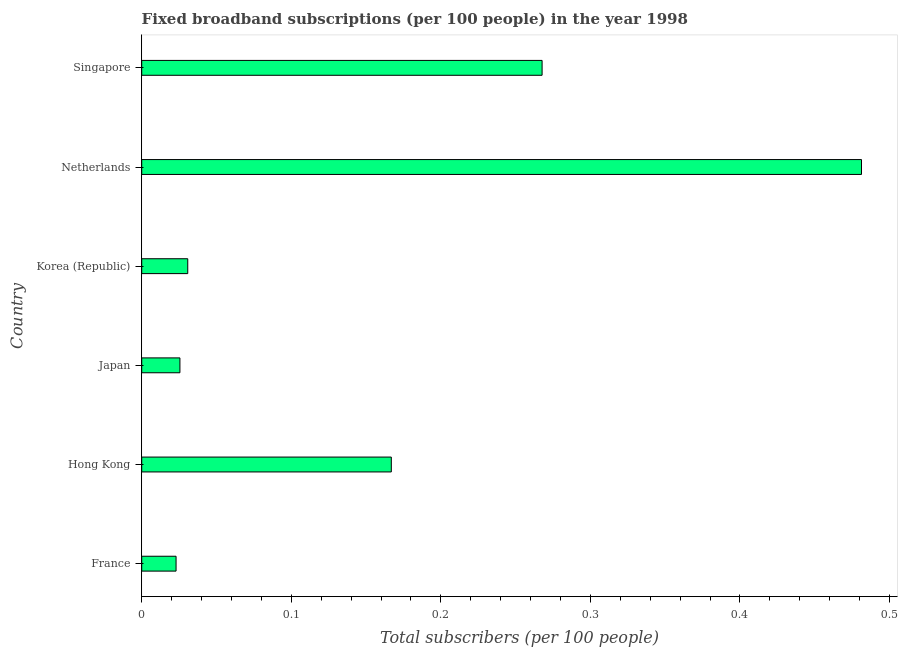What is the title of the graph?
Your response must be concise. Fixed broadband subscriptions (per 100 people) in the year 1998. What is the label or title of the X-axis?
Provide a succinct answer. Total subscribers (per 100 people). What is the label or title of the Y-axis?
Give a very brief answer. Country. What is the total number of fixed broadband subscriptions in Netherlands?
Provide a succinct answer. 0.48. Across all countries, what is the maximum total number of fixed broadband subscriptions?
Provide a succinct answer. 0.48. Across all countries, what is the minimum total number of fixed broadband subscriptions?
Offer a very short reply. 0.02. In which country was the total number of fixed broadband subscriptions minimum?
Give a very brief answer. France. What is the sum of the total number of fixed broadband subscriptions?
Offer a very short reply. 1. What is the difference between the total number of fixed broadband subscriptions in France and Japan?
Provide a short and direct response. -0. What is the average total number of fixed broadband subscriptions per country?
Make the answer very short. 0.17. What is the median total number of fixed broadband subscriptions?
Your answer should be very brief. 0.1. In how many countries, is the total number of fixed broadband subscriptions greater than 0.18 ?
Provide a short and direct response. 2. What is the ratio of the total number of fixed broadband subscriptions in France to that in Singapore?
Provide a short and direct response. 0.09. Is the total number of fixed broadband subscriptions in Hong Kong less than that in Singapore?
Provide a succinct answer. Yes. Is the difference between the total number of fixed broadband subscriptions in France and Korea (Republic) greater than the difference between any two countries?
Your answer should be very brief. No. What is the difference between the highest and the second highest total number of fixed broadband subscriptions?
Your response must be concise. 0.21. What is the difference between the highest and the lowest total number of fixed broadband subscriptions?
Provide a succinct answer. 0.46. How many countries are there in the graph?
Provide a succinct answer. 6. What is the difference between two consecutive major ticks on the X-axis?
Your response must be concise. 0.1. Are the values on the major ticks of X-axis written in scientific E-notation?
Ensure brevity in your answer.  No. What is the Total subscribers (per 100 people) of France?
Offer a very short reply. 0.02. What is the Total subscribers (per 100 people) of Hong Kong?
Make the answer very short. 0.17. What is the Total subscribers (per 100 people) in Japan?
Provide a short and direct response. 0.03. What is the Total subscribers (per 100 people) of Korea (Republic)?
Offer a terse response. 0.03. What is the Total subscribers (per 100 people) of Netherlands?
Your response must be concise. 0.48. What is the Total subscribers (per 100 people) in Singapore?
Ensure brevity in your answer.  0.27. What is the difference between the Total subscribers (per 100 people) in France and Hong Kong?
Give a very brief answer. -0.14. What is the difference between the Total subscribers (per 100 people) in France and Japan?
Make the answer very short. -0. What is the difference between the Total subscribers (per 100 people) in France and Korea (Republic)?
Give a very brief answer. -0.01. What is the difference between the Total subscribers (per 100 people) in France and Netherlands?
Provide a short and direct response. -0.46. What is the difference between the Total subscribers (per 100 people) in France and Singapore?
Provide a short and direct response. -0.24. What is the difference between the Total subscribers (per 100 people) in Hong Kong and Japan?
Your response must be concise. 0.14. What is the difference between the Total subscribers (per 100 people) in Hong Kong and Korea (Republic)?
Ensure brevity in your answer.  0.14. What is the difference between the Total subscribers (per 100 people) in Hong Kong and Netherlands?
Offer a very short reply. -0.31. What is the difference between the Total subscribers (per 100 people) in Hong Kong and Singapore?
Give a very brief answer. -0.1. What is the difference between the Total subscribers (per 100 people) in Japan and Korea (Republic)?
Offer a terse response. -0.01. What is the difference between the Total subscribers (per 100 people) in Japan and Netherlands?
Provide a short and direct response. -0.46. What is the difference between the Total subscribers (per 100 people) in Japan and Singapore?
Provide a short and direct response. -0.24. What is the difference between the Total subscribers (per 100 people) in Korea (Republic) and Netherlands?
Provide a short and direct response. -0.45. What is the difference between the Total subscribers (per 100 people) in Korea (Republic) and Singapore?
Provide a short and direct response. -0.24. What is the difference between the Total subscribers (per 100 people) in Netherlands and Singapore?
Provide a succinct answer. 0.21. What is the ratio of the Total subscribers (per 100 people) in France to that in Hong Kong?
Offer a terse response. 0.14. What is the ratio of the Total subscribers (per 100 people) in France to that in Japan?
Your response must be concise. 0.9. What is the ratio of the Total subscribers (per 100 people) in France to that in Korea (Republic)?
Give a very brief answer. 0.75. What is the ratio of the Total subscribers (per 100 people) in France to that in Netherlands?
Make the answer very short. 0.05. What is the ratio of the Total subscribers (per 100 people) in France to that in Singapore?
Provide a succinct answer. 0.09. What is the ratio of the Total subscribers (per 100 people) in Hong Kong to that in Japan?
Offer a very short reply. 6.53. What is the ratio of the Total subscribers (per 100 people) in Hong Kong to that in Korea (Republic)?
Offer a terse response. 5.42. What is the ratio of the Total subscribers (per 100 people) in Hong Kong to that in Netherlands?
Ensure brevity in your answer.  0.35. What is the ratio of the Total subscribers (per 100 people) in Hong Kong to that in Singapore?
Offer a very short reply. 0.62. What is the ratio of the Total subscribers (per 100 people) in Japan to that in Korea (Republic)?
Give a very brief answer. 0.83. What is the ratio of the Total subscribers (per 100 people) in Japan to that in Netherlands?
Your response must be concise. 0.05. What is the ratio of the Total subscribers (per 100 people) in Japan to that in Singapore?
Offer a very short reply. 0.1. What is the ratio of the Total subscribers (per 100 people) in Korea (Republic) to that in Netherlands?
Your answer should be very brief. 0.06. What is the ratio of the Total subscribers (per 100 people) in Korea (Republic) to that in Singapore?
Your response must be concise. 0.12. What is the ratio of the Total subscribers (per 100 people) in Netherlands to that in Singapore?
Keep it short and to the point. 1.8. 